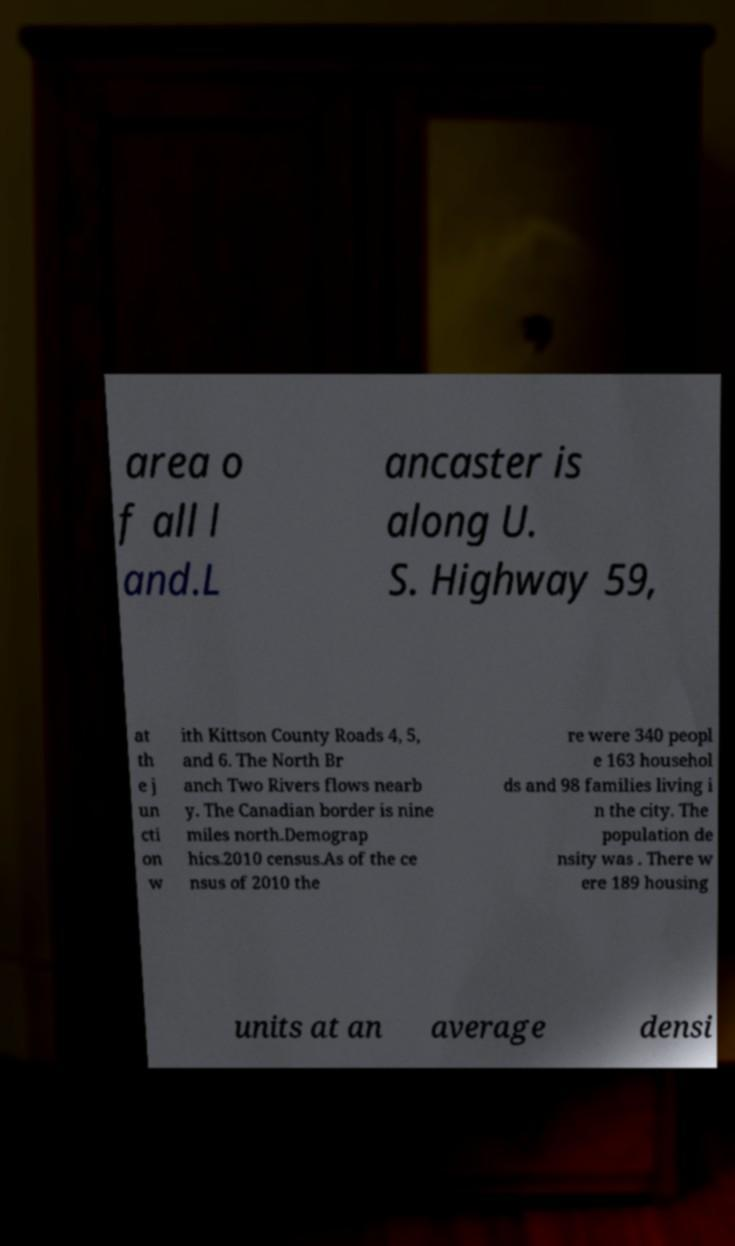Please read and relay the text visible in this image. What does it say? area o f all l and.L ancaster is along U. S. Highway 59, at th e j un cti on w ith Kittson County Roads 4, 5, and 6. The North Br anch Two Rivers flows nearb y. The Canadian border is nine miles north.Demograp hics.2010 census.As of the ce nsus of 2010 the re were 340 peopl e 163 househol ds and 98 families living i n the city. The population de nsity was . There w ere 189 housing units at an average densi 